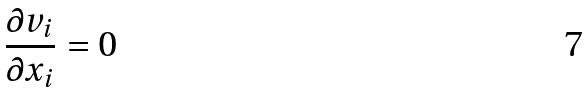<formula> <loc_0><loc_0><loc_500><loc_500>\frac { \partial v _ { i } } { \partial x _ { i } } = 0</formula> 